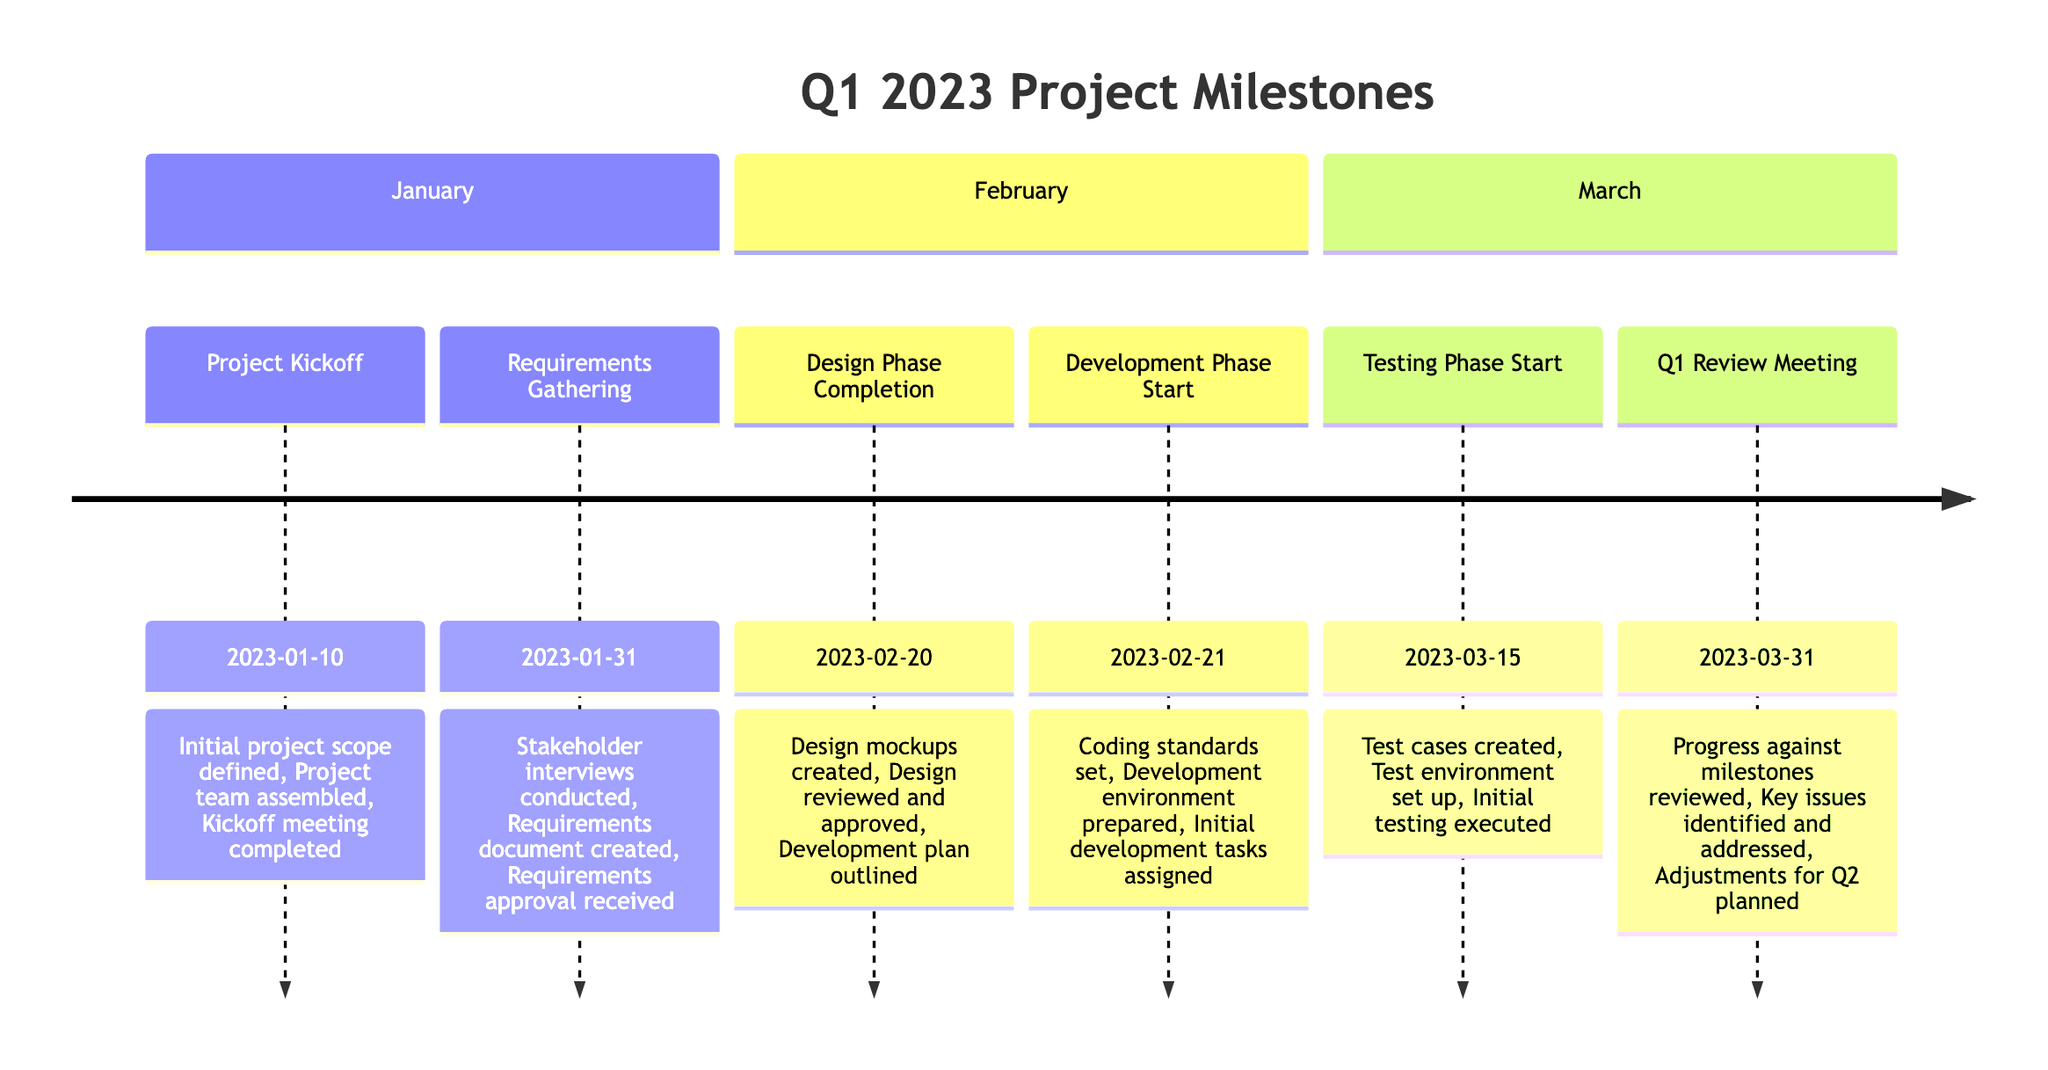What is the date of the Project Kickoff? The Project Kickoff milestone is listed with the date next to it, which is "2023-01-10."
Answer: 2023-01-10 How many milestones are there in total? By counting each milestone listed in the diagram sequentially, we find there are a total of six distinct milestones: Project Kickoff, Requirements Gathering, Design Phase Completion, Development Phase Start, Testing Phase Start, and Q1 Review Meeting.
Answer: 6 What key deliverable is associated with the Requirements Gathering milestone? The Requirements Gathering milestone has three key deliverables, including "Stakeholder interviews conducted," "Requirements document created," and "Requirements approval received." One of these, like "Requirements document created," can be selected as an answer.
Answer: Requirements document created Which milestone occurs last in the timeline? By checking the order of milestones and their dates, the last milestone that occurs in the timeline is the Q1 Review Meeting on date "2023-03-31."
Answer: Q1 Review Meeting What are the key deliverables for the Design Phase Completion? For the Design Phase Completion milestone, the key deliverables listed are "Design mockups created," "Design reviewed and approved," and "Development plan outlined." Listing them provides an effective answer.
Answer: Design mockups created, Design reviewed and approved, Development plan outlined What milestone directly precedes the Testing Phase Start? To find the milestone preceding the Testing Phase Start, look at the timeline and the sequence of the milestones. It is evident that the Development Phase Start comes directly before the Testing Phase Start.
Answer: Development Phase Start What is the first milestone of Q1 2023? The first milestone in the timeline, as listed among the milestones, is the Project Kickoff, which is provided as the first entry in the timeline.
Answer: Project Kickoff What key issue will be addressed during the Q1 Review Meeting? During the Q1 Review Meeting milestone, one of the key deliverables includes "Key issues identified and addressed," indicating a proactive step discussed during that meeting. As this is a general inquiry, a specific key issue cannot be pinpointed without additional context.
Answer: Key issues identified and addressed What starts after the Design Phase Completion? The milestone following the Design Phase Completion is the Development Phase Start, indicating the next step in the project timeline.
Answer: Development Phase Start 